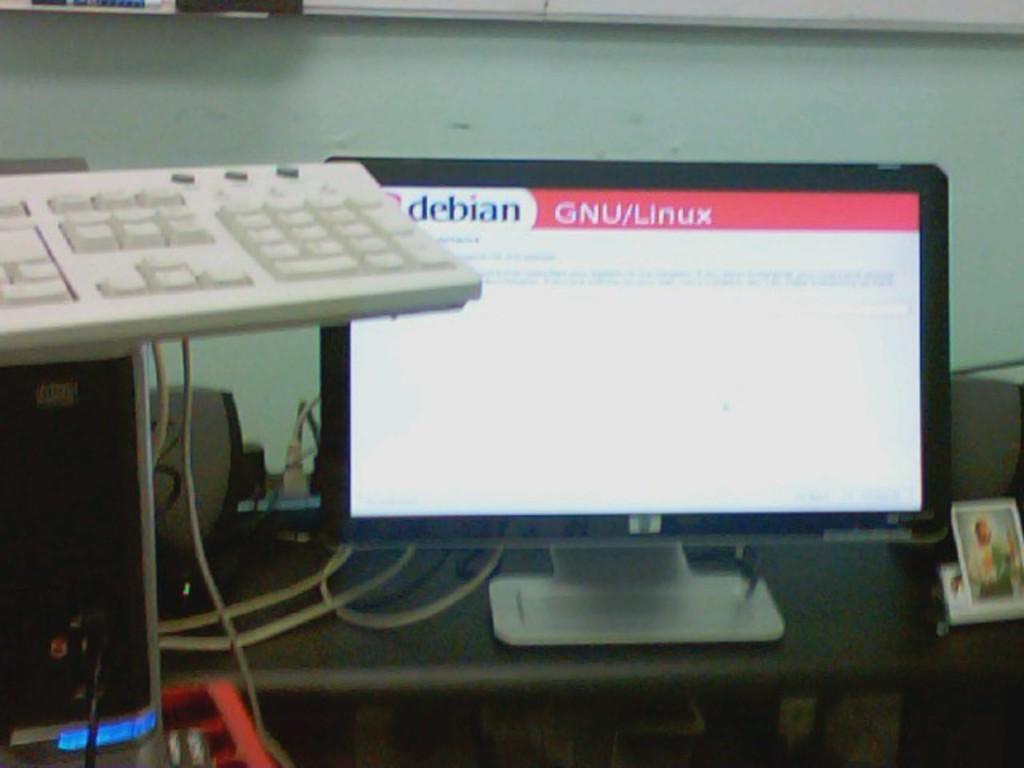Describe this image in one or two sentences. In this image there is a monitor in the center and on the left side there is a CPU on the CPU there is a keyboard which is white in colour. In the center on the table there are wires, there is a speaker, and there is a frame. In the background there is a wall which is green in colour. 